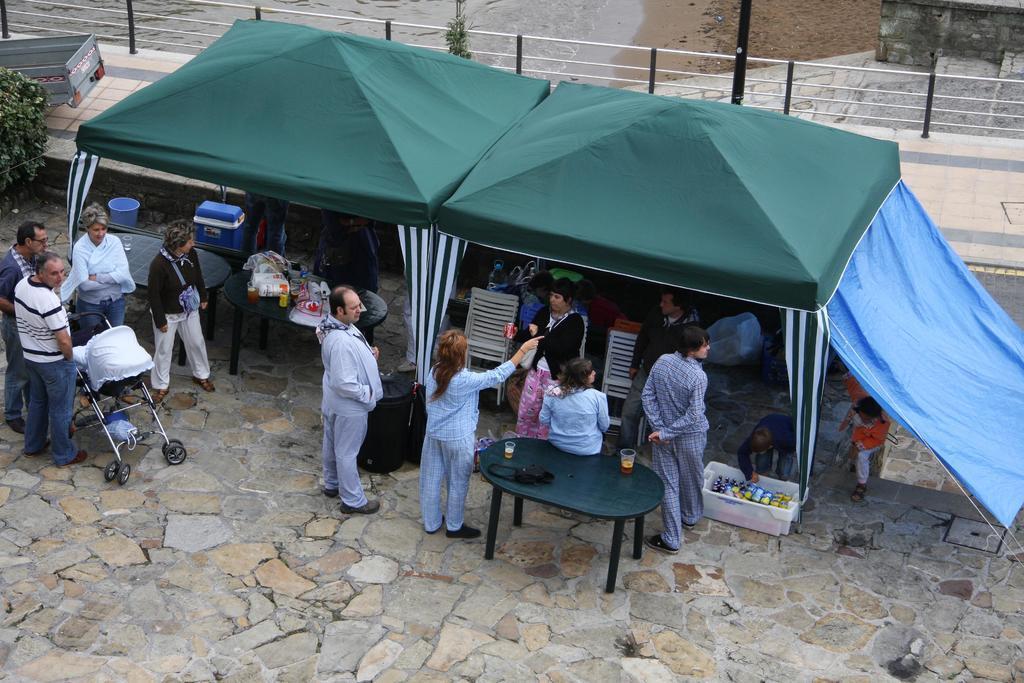In one or two sentences, can you explain what this image depicts? In this image I can see number of people where one is sitting on table and rest all are standing. I can also see a vehicle, a tree, few baskets, chairs and a tent. 